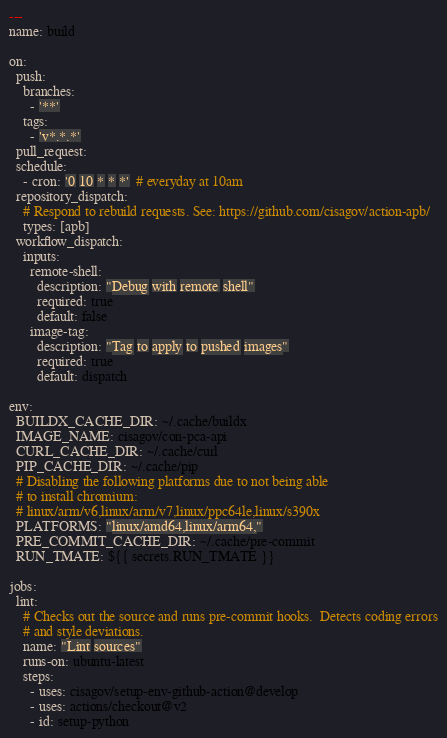<code> <loc_0><loc_0><loc_500><loc_500><_YAML_>---
name: build

on:
  push:
    branches:
      - '**'
    tags:
      - 'v*.*.*'
  pull_request:
  schedule:
    - cron: '0 10 * * *'  # everyday at 10am
  repository_dispatch:
    # Respond to rebuild requests. See: https://github.com/cisagov/action-apb/
    types: [apb]
  workflow_dispatch:
    inputs:
      remote-shell:
        description: "Debug with remote shell"
        required: true
        default: false
      image-tag:
        description: "Tag to apply to pushed images"
        required: true
        default: dispatch

env:
  BUILDX_CACHE_DIR: ~/.cache/buildx
  IMAGE_NAME: cisagov/con-pca-api
  CURL_CACHE_DIR: ~/.cache/curl
  PIP_CACHE_DIR: ~/.cache/pip
  # Disabling the following platforms due to not being able
  # to install chromium:
  # linux/arm/v6,linux/arm/v7,linux/ppc64le,linux/s390x
  PLATFORMS: "linux/amd64,linux/arm64,"
  PRE_COMMIT_CACHE_DIR: ~/.cache/pre-commit
  RUN_TMATE: ${{ secrets.RUN_TMATE }}

jobs:
  lint:
    # Checks out the source and runs pre-commit hooks.  Detects coding errors
    # and style deviations.
    name: "Lint sources"
    runs-on: ubuntu-latest
    steps:
      - uses: cisagov/setup-env-github-action@develop
      - uses: actions/checkout@v2
      - id: setup-python</code> 